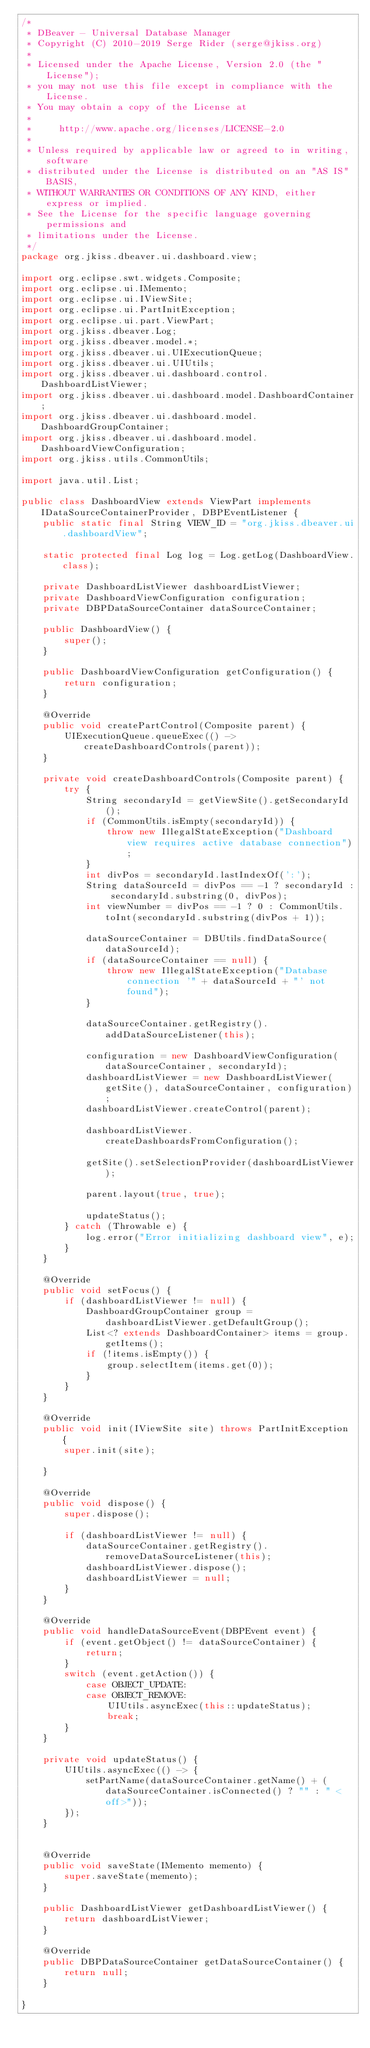Convert code to text. <code><loc_0><loc_0><loc_500><loc_500><_Java_>/*
 * DBeaver - Universal Database Manager
 * Copyright (C) 2010-2019 Serge Rider (serge@jkiss.org)
 *
 * Licensed under the Apache License, Version 2.0 (the "License");
 * you may not use this file except in compliance with the License.
 * You may obtain a copy of the License at
 *
 *     http://www.apache.org/licenses/LICENSE-2.0
 *
 * Unless required by applicable law or agreed to in writing, software
 * distributed under the License is distributed on an "AS IS" BASIS,
 * WITHOUT WARRANTIES OR CONDITIONS OF ANY KIND, either express or implied.
 * See the License for the specific language governing permissions and
 * limitations under the License.
 */
package org.jkiss.dbeaver.ui.dashboard.view;

import org.eclipse.swt.widgets.Composite;
import org.eclipse.ui.IMemento;
import org.eclipse.ui.IViewSite;
import org.eclipse.ui.PartInitException;
import org.eclipse.ui.part.ViewPart;
import org.jkiss.dbeaver.Log;
import org.jkiss.dbeaver.model.*;
import org.jkiss.dbeaver.ui.UIExecutionQueue;
import org.jkiss.dbeaver.ui.UIUtils;
import org.jkiss.dbeaver.ui.dashboard.control.DashboardListViewer;
import org.jkiss.dbeaver.ui.dashboard.model.DashboardContainer;
import org.jkiss.dbeaver.ui.dashboard.model.DashboardGroupContainer;
import org.jkiss.dbeaver.ui.dashboard.model.DashboardViewConfiguration;
import org.jkiss.utils.CommonUtils;

import java.util.List;

public class DashboardView extends ViewPart implements IDataSourceContainerProvider, DBPEventListener {
    public static final String VIEW_ID = "org.jkiss.dbeaver.ui.dashboardView";

    static protected final Log log = Log.getLog(DashboardView.class);

    private DashboardListViewer dashboardListViewer;
    private DashboardViewConfiguration configuration;
    private DBPDataSourceContainer dataSourceContainer;

    public DashboardView() {
        super();
    }

    public DashboardViewConfiguration getConfiguration() {
        return configuration;
    }

    @Override
    public void createPartControl(Composite parent) {
        UIExecutionQueue.queueExec(() -> createDashboardControls(parent));
    }

    private void createDashboardControls(Composite parent) {
        try {
            String secondaryId = getViewSite().getSecondaryId();
            if (CommonUtils.isEmpty(secondaryId)) {
                throw new IllegalStateException("Dashboard view requires active database connection");
            }
            int divPos = secondaryId.lastIndexOf(':');
            String dataSourceId = divPos == -1 ? secondaryId : secondaryId.substring(0, divPos);
            int viewNumber = divPos == -1 ? 0 : CommonUtils.toInt(secondaryId.substring(divPos + 1));

            dataSourceContainer = DBUtils.findDataSource(dataSourceId);
            if (dataSourceContainer == null) {
                throw new IllegalStateException("Database connection '" + dataSourceId + "' not found");
            }

            dataSourceContainer.getRegistry().addDataSourceListener(this);

            configuration = new DashboardViewConfiguration(dataSourceContainer, secondaryId);
            dashboardListViewer = new DashboardListViewer(getSite(), dataSourceContainer, configuration);
            dashboardListViewer.createControl(parent);

            dashboardListViewer.createDashboardsFromConfiguration();

            getSite().setSelectionProvider(dashboardListViewer);

            parent.layout(true, true);

            updateStatus();
        } catch (Throwable e) {
            log.error("Error initializing dashboard view", e);
        }
    }

    @Override
    public void setFocus() {
        if (dashboardListViewer != null) {
            DashboardGroupContainer group = dashboardListViewer.getDefaultGroup();
            List<? extends DashboardContainer> items = group.getItems();
            if (!items.isEmpty()) {
                group.selectItem(items.get(0));
            }
        }
    }

    @Override
    public void init(IViewSite site) throws PartInitException {
        super.init(site);

    }

    @Override
    public void dispose() {
        super.dispose();

        if (dashboardListViewer != null) {
            dataSourceContainer.getRegistry().removeDataSourceListener(this);
            dashboardListViewer.dispose();
            dashboardListViewer = null;
        }
    }

    @Override
    public void handleDataSourceEvent(DBPEvent event) {
        if (event.getObject() != dataSourceContainer) {
            return;
        }
        switch (event.getAction()) {
            case OBJECT_UPDATE:
            case OBJECT_REMOVE:
                UIUtils.asyncExec(this::updateStatus);
                break;
        }
    }

    private void updateStatus() {
        UIUtils.asyncExec(() -> {
            setPartName(dataSourceContainer.getName() + (dataSourceContainer.isConnected() ? "" : " <off>"));
        });
    }


    @Override
    public void saveState(IMemento memento) {
        super.saveState(memento);
    }

    public DashboardListViewer getDashboardListViewer() {
        return dashboardListViewer;
    }

    @Override
    public DBPDataSourceContainer getDataSourceContainer() {
        return null;
    }

}
</code> 